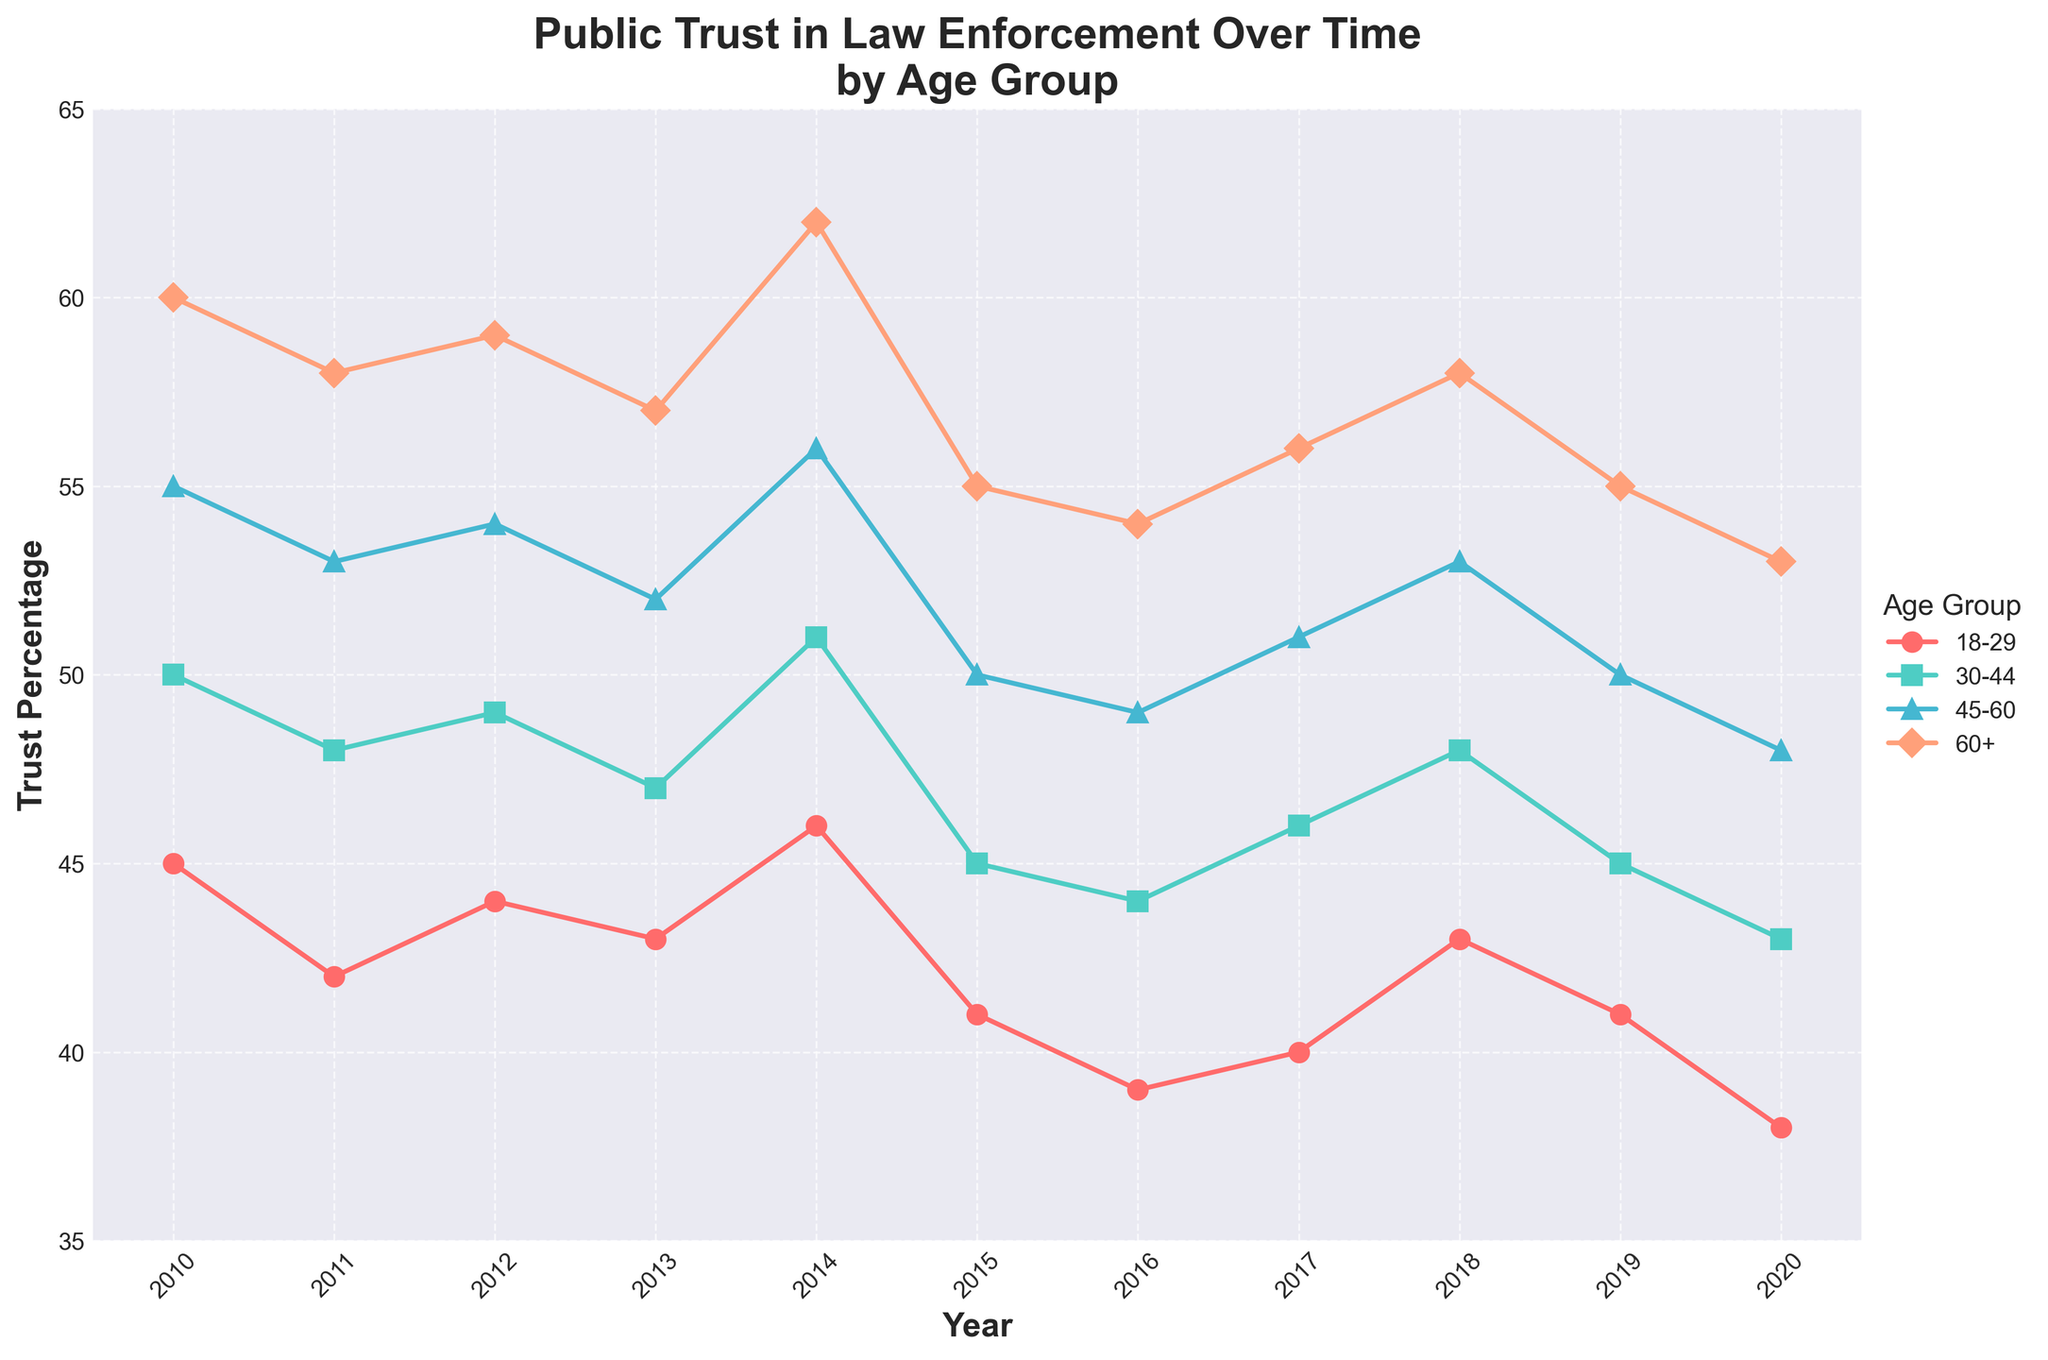What's the title of the plot? The title is displayed at the top of the figure and reads "Public Trust in Law Enforcement Over Time by Age Group".
Answer: Public Trust in Law Enforcement Over Time by Age Group Which age group shows the highest trust percentage in 2020? In 2020, the line for the 60+ age group is at the highest point on the graph, reaching around 53.
Answer: 60+ Which year had the lowest trust percentage for the 18-29 age group? By observing the 18-29 age group's line, the lowest point occurs in 2020 where it reaches around 38.
Answer: 2020 How does the trust percentage for the 30-44 age group in 2015 compare to 2010? In 2010, the trust percentage for the 30-44 age group is about 50, while in 2015 it drops to 45, indicating a decrease.
Answer: It decreased What is the average trust percentage for the 45-60 age group from 2010 to 2020? Add the trust percentages for 45-60 age group from 2010 (55), 2011 (53), 2012 (54), 2013 (52), 2014 (56), 2015 (50), 2016 (49), 2017 (51), 2018 (53), 2019 (50), 2020 (48), then divide by the number of years (11). The sum is 571; average = 571/11 ≈ 51.9.
Answer: 51.9 In which year did the 60+ age group experience its peak trust percentage? By tracing the line for the 60+ age group, the peak occurs in 2014 where the trust percentage reaches 62.
Answer: 2014 Is there any age group whose trust percentage never falls below 40 during the period from 2010 to 2020? By examining the lines for all age groups, the 60+ age group never falls below 40, maintaining a minimum of around 53.
Answer: 60+ How does the trust percentage trend for the 18-29 age group change from 2010 to 2020? Starting from 2010 at 45, the 18-29 age group's trust percentage generally decreases, hitting a low of 38 in 2020.
Answer: It decreases Which age group had the smallest change in trust percentage from 2010 to 2020? Calculate the difference for each age group between 2010 and 2020: 18-29 (45-38=7), 30-44 (50-43=7), 45-60 (55-48=7), 60+ (60-53=7). They all show an equal change of 7 percentage points.
Answer: All age groups had the same change Is the trust percentage for the 18-29 group always lower than the 60+ group throughout the years? By comparing the positions of the 18-29 line and the 60+ line year by year, the 18-29 group always has a lower trust percentage than the 60+ group.
Answer: Yes 